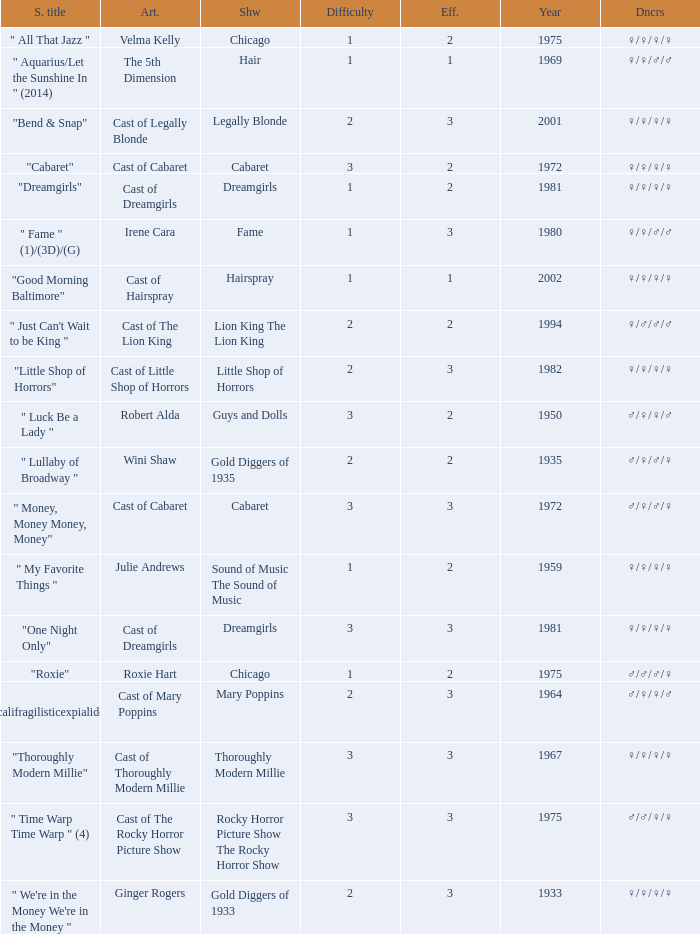How many shows were in 1994? 1.0. 